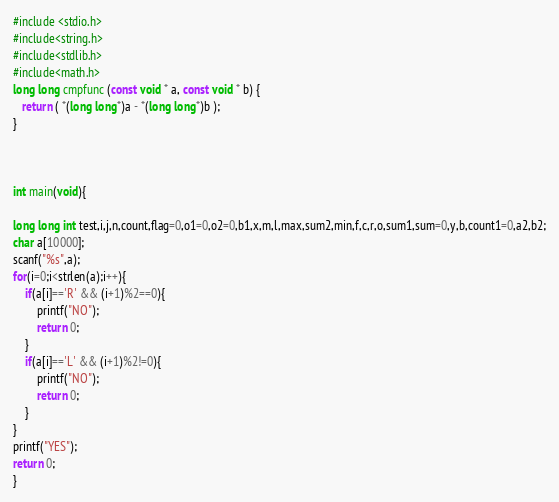Convert code to text. <code><loc_0><loc_0><loc_500><loc_500><_C_>#include <stdio.h>
#include<string.h>
#include<stdlib.h>
#include<math.h>
long long cmpfunc (const void * a, const void * b) {
   return ( *(long long*)a - *(long long*)b );
}



int main(void){
   
long long int test,i,j,n,count,flag=0,o1=0,o2=0,b1,x,m,l,max,sum2,min,f,c,r,o,sum1,sum=0,y,b,count1=0,a2,b2;
char a[10000];
scanf("%s",a);
for(i=0;i<strlen(a);i++){
    if(a[i]=='R' && (i+1)%2==0){
        printf("NO");
        return 0;
    }
    if(a[i]=='L' && (i+1)%2!=0){
        printf("NO");
        return 0;
    }
}
printf("YES");
return 0;
}
</code> 